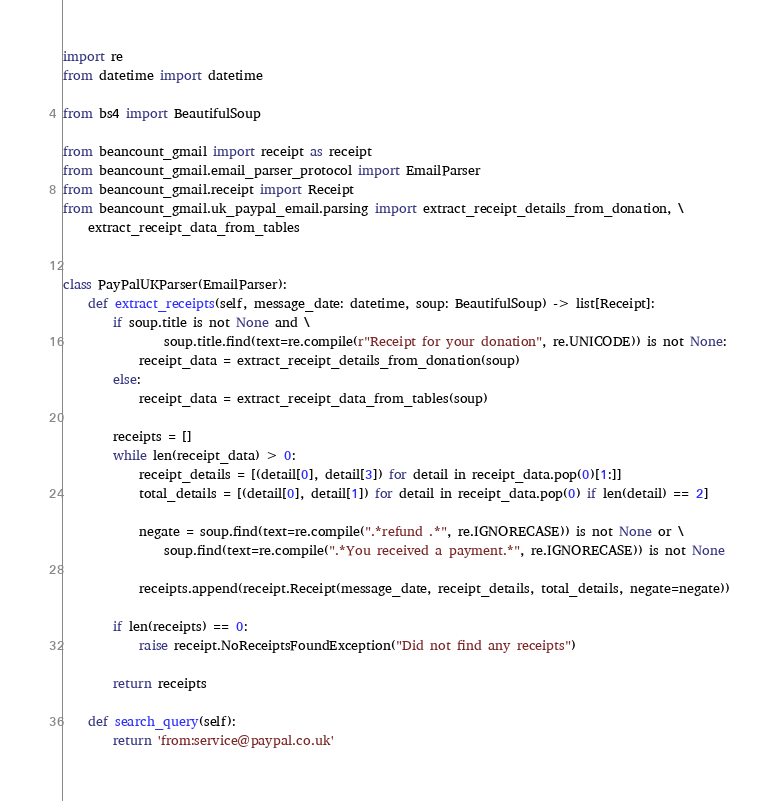Convert code to text. <code><loc_0><loc_0><loc_500><loc_500><_Python_>import re
from datetime import datetime

from bs4 import BeautifulSoup

from beancount_gmail import receipt as receipt
from beancount_gmail.email_parser_protocol import EmailParser
from beancount_gmail.receipt import Receipt
from beancount_gmail.uk_paypal_email.parsing import extract_receipt_details_from_donation, \
    extract_receipt_data_from_tables


class PayPalUKParser(EmailParser):
    def extract_receipts(self, message_date: datetime, soup: BeautifulSoup) -> list[Receipt]:
        if soup.title is not None and \
                soup.title.find(text=re.compile(r"Receipt for your donation", re.UNICODE)) is not None:
            receipt_data = extract_receipt_details_from_donation(soup)
        else:
            receipt_data = extract_receipt_data_from_tables(soup)

        receipts = []
        while len(receipt_data) > 0:
            receipt_details = [(detail[0], detail[3]) for detail in receipt_data.pop(0)[1:]]
            total_details = [(detail[0], detail[1]) for detail in receipt_data.pop(0) if len(detail) == 2]

            negate = soup.find(text=re.compile(".*refund .*", re.IGNORECASE)) is not None or \
                soup.find(text=re.compile(".*You received a payment.*", re.IGNORECASE)) is not None

            receipts.append(receipt.Receipt(message_date, receipt_details, total_details, negate=negate))

        if len(receipts) == 0:
            raise receipt.NoReceiptsFoundException("Did not find any receipts")

        return receipts

    def search_query(self):
        return 'from:service@paypal.co.uk'
</code> 